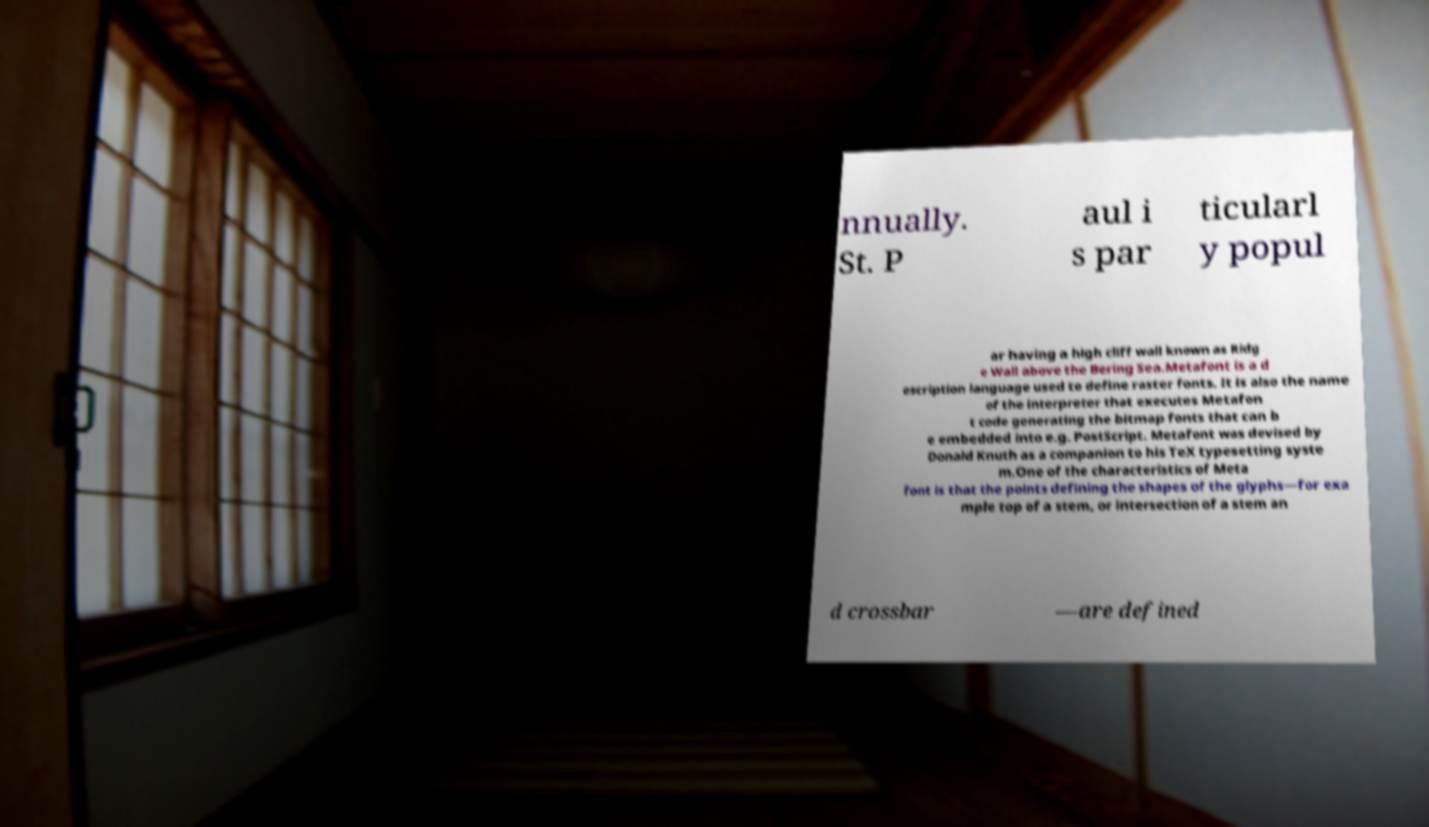Please identify and transcribe the text found in this image. nnually. St. P aul i s par ticularl y popul ar having a high cliff wall known as Ridg e Wall above the Bering Sea.Metafont is a d escription language used to define raster fonts. It is also the name of the interpreter that executes Metafon t code generating the bitmap fonts that can b e embedded into e.g. PostScript. Metafont was devised by Donald Knuth as a companion to his TeX typesetting syste m.One of the characteristics of Meta font is that the points defining the shapes of the glyphs—for exa mple top of a stem, or intersection of a stem an d crossbar —are defined 